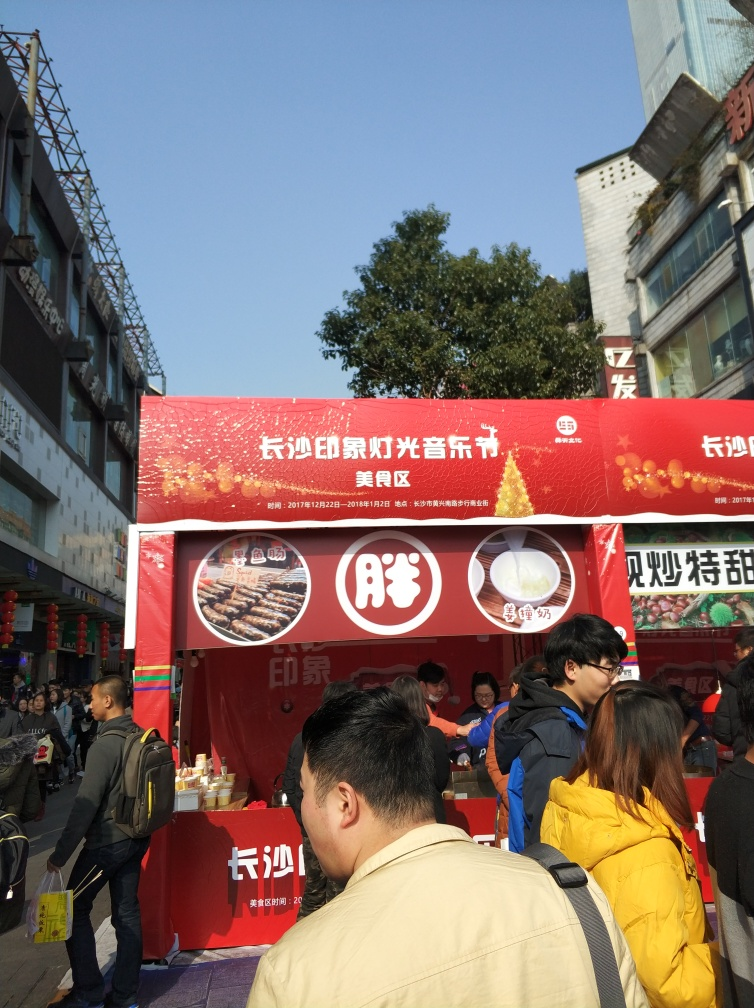Is the overall clarity of the image high? The image is quite clear, with good lighting and sharp details, allowing the viewer to easily make out the text on the banners and the activities of the people around the food stall. 